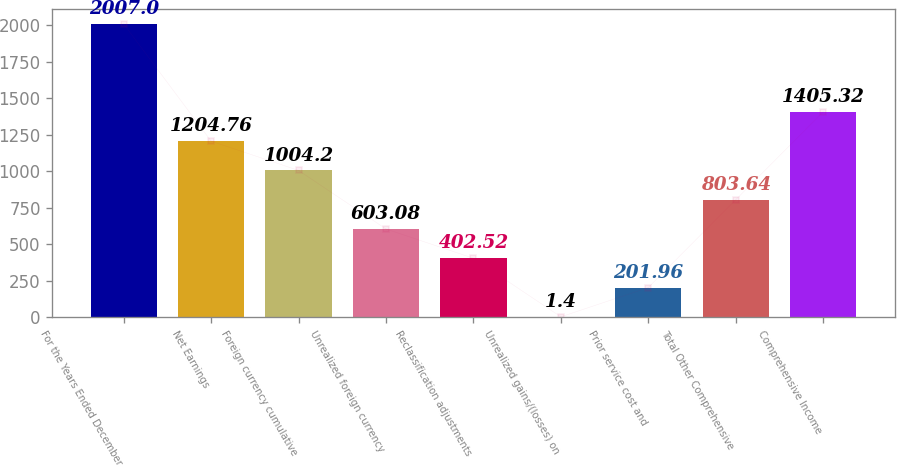Convert chart to OTSL. <chart><loc_0><loc_0><loc_500><loc_500><bar_chart><fcel>For the Years Ended December<fcel>Net Earnings<fcel>Foreign currency cumulative<fcel>Unrealized foreign currency<fcel>Reclassification adjustments<fcel>Unrealized gains/(losses) on<fcel>Prior service cost and<fcel>Total Other Comprehensive<fcel>Comprehensive Income<nl><fcel>2007<fcel>1204.76<fcel>1004.2<fcel>603.08<fcel>402.52<fcel>1.4<fcel>201.96<fcel>803.64<fcel>1405.32<nl></chart> 